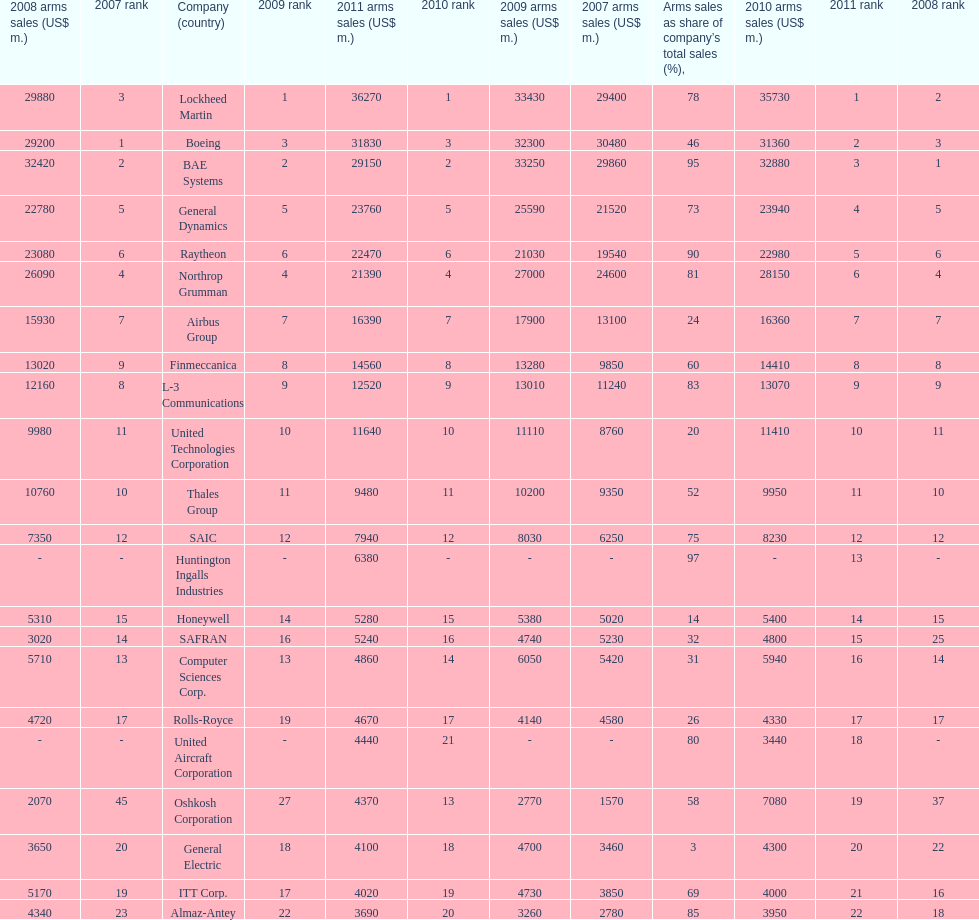Which is the only company to have under 10% arms sales as share of company's total sales? General Electric. Could you parse the entire table? {'header': ['2008 arms sales (US$ m.)', '2007 rank', 'Company (country)', '2009 rank', '2011 arms sales (US$ m.)', '2010 rank', '2009 arms sales (US$ m.)', '2007 arms sales (US$ m.)', 'Arms sales as share of company’s total sales (%),', '2010 arms sales (US$ m.)', '2011 rank', '2008 rank'], 'rows': [['29880', '3', 'Lockheed Martin', '1', '36270', '1', '33430', '29400', '78', '35730', '1', '2'], ['29200', '1', 'Boeing', '3', '31830', '3', '32300', '30480', '46', '31360', '2', '3'], ['32420', '2', 'BAE Systems', '2', '29150', '2', '33250', '29860', '95', '32880', '3', '1'], ['22780', '5', 'General Dynamics', '5', '23760', '5', '25590', '21520', '73', '23940', '4', '5'], ['23080', '6', 'Raytheon', '6', '22470', '6', '21030', '19540', '90', '22980', '5', '6'], ['26090', '4', 'Northrop Grumman', '4', '21390', '4', '27000', '24600', '81', '28150', '6', '4'], ['15930', '7', 'Airbus Group', '7', '16390', '7', '17900', '13100', '24', '16360', '7', '7'], ['13020', '9', 'Finmeccanica', '8', '14560', '8', '13280', '9850', '60', '14410', '8', '8'], ['12160', '8', 'L-3 Communications', '9', '12520', '9', '13010', '11240', '83', '13070', '9', '9'], ['9980', '11', 'United Technologies Corporation', '10', '11640', '10', '11110', '8760', '20', '11410', '10', '11'], ['10760', '10', 'Thales Group', '11', '9480', '11', '10200', '9350', '52', '9950', '11', '10'], ['7350', '12', 'SAIC', '12', '7940', '12', '8030', '6250', '75', '8230', '12', '12'], ['-', '-', 'Huntington Ingalls Industries', '-', '6380', '-', '-', '-', '97', '-', '13', '-'], ['5310', '15', 'Honeywell', '14', '5280', '15', '5380', '5020', '14', '5400', '14', '15'], ['3020', '14', 'SAFRAN', '16', '5240', '16', '4740', '5230', '32', '4800', '15', '25'], ['5710', '13', 'Computer Sciences Corp.', '13', '4860', '14', '6050', '5420', '31', '5940', '16', '14'], ['4720', '17', 'Rolls-Royce', '19', '4670', '17', '4140', '4580', '26', '4330', '17', '17'], ['-', '-', 'United Aircraft Corporation', '-', '4440', '21', '-', '-', '80', '3440', '18', '-'], ['2070', '45', 'Oshkosh Corporation', '27', '4370', '13', '2770', '1570', '58', '7080', '19', '37'], ['3650', '20', 'General Electric', '18', '4100', '18', '4700', '3460', '3', '4300', '20', '22'], ['5170', '19', 'ITT Corp.', '17', '4020', '19', '4730', '3850', '69', '4000', '21', '16'], ['4340', '23', 'Almaz-Antey', '22', '3690', '20', '3260', '2780', '85', '3950', '22', '18']]} 